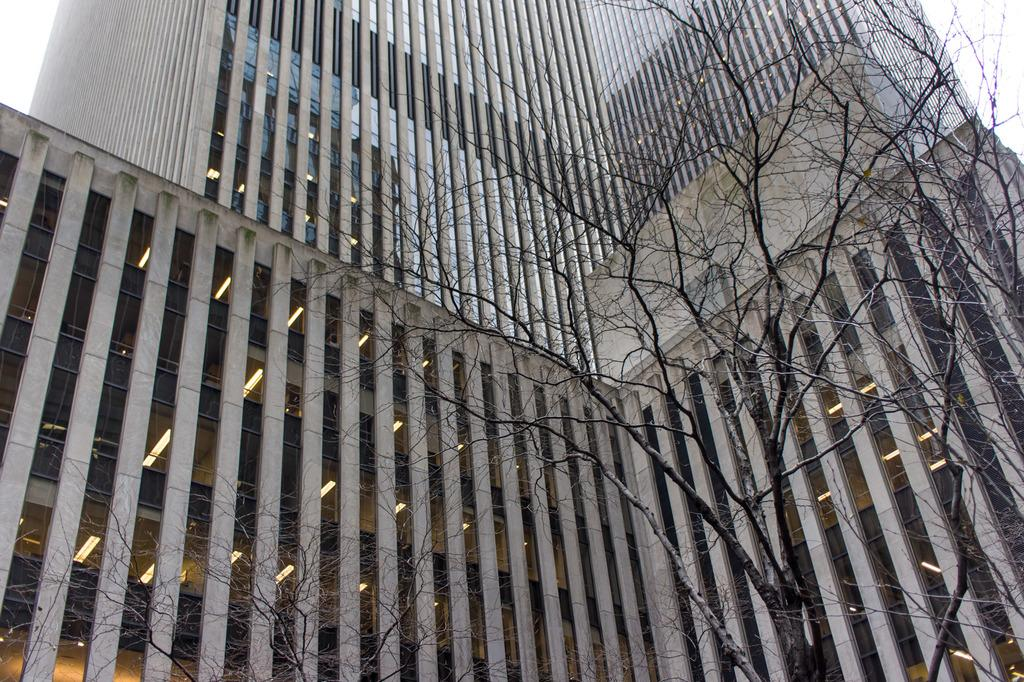What type of structures can be seen in the image? There are buildings in the image. What is the condition of the trees in the image? The trees in the image are dry. What is visible at the top of the image? The sky is visible at the top of the image. What route is the minister taking in the image? There is no minister or route present in the image. What type of scene is depicted in the image? The image depicts a scene with buildings and dry trees, with the sky visible at the top. 